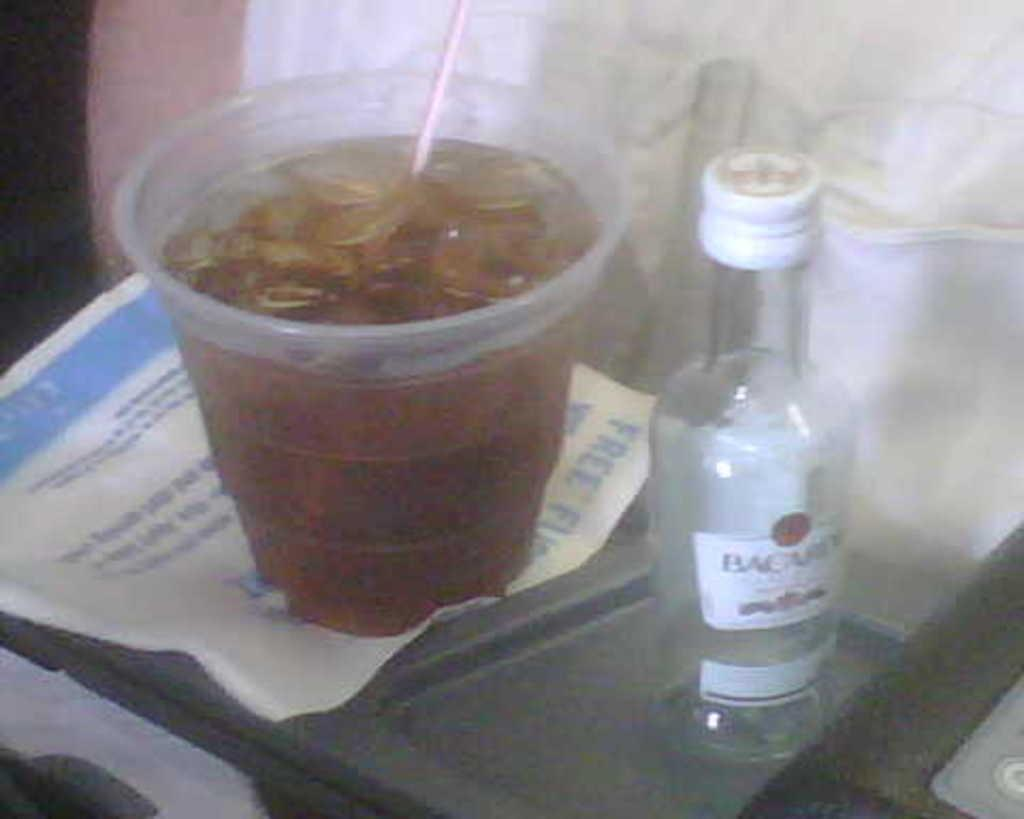<image>
Give a short and clear explanation of the subsequent image. A bottle of Bacardi sits next to a cup with a straw in it. 